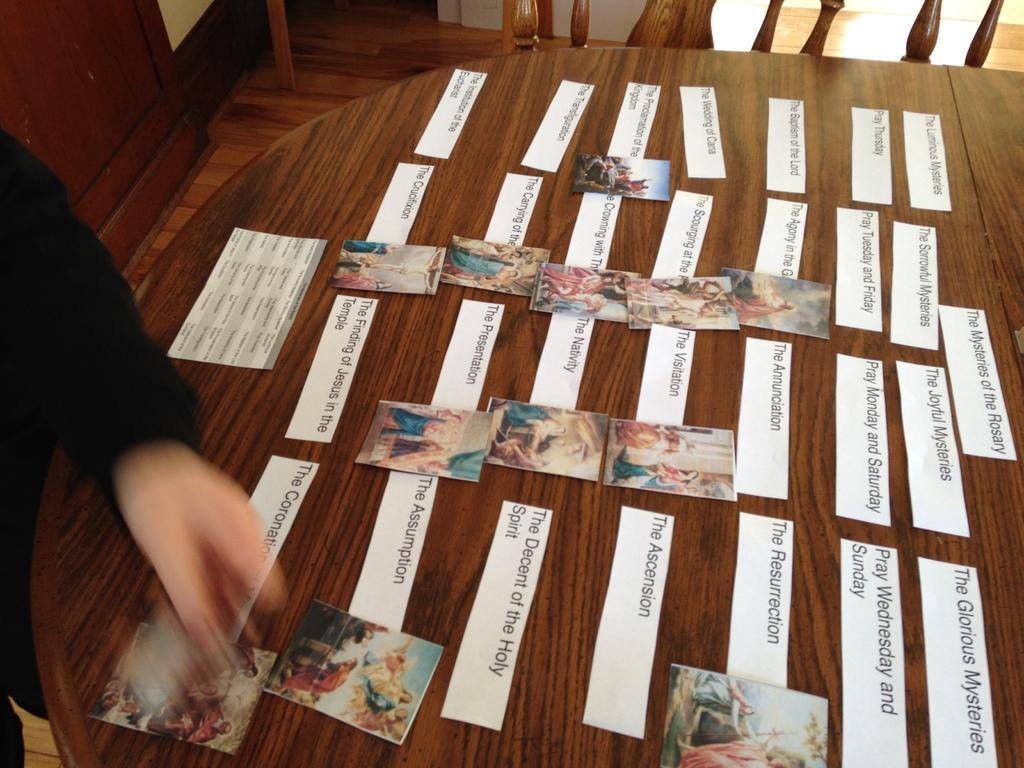What is on the table in the image? There are posters with text and images on a table. What type of material can be seen among the objects in the image? There are wooden objects visible in the image. What can be seen beneath the table and other objects in the image? The ground is visible in the image. Can you describe the object located in the top left corner of the image? There is an object in the top left corner of the image, but without more information, it is difficult to provide a detailed description. How does the jellyfish move around on the table in the image? There is no jellyfish present in the image; it is not a relevant subject for this conversation. 